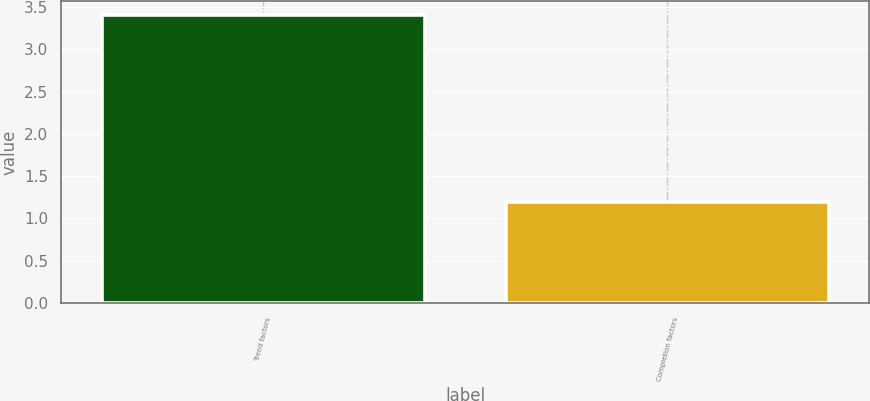Convert chart. <chart><loc_0><loc_0><loc_500><loc_500><bar_chart><fcel>Trend factors<fcel>Completion factors<nl><fcel>3.4<fcel>1.2<nl></chart> 